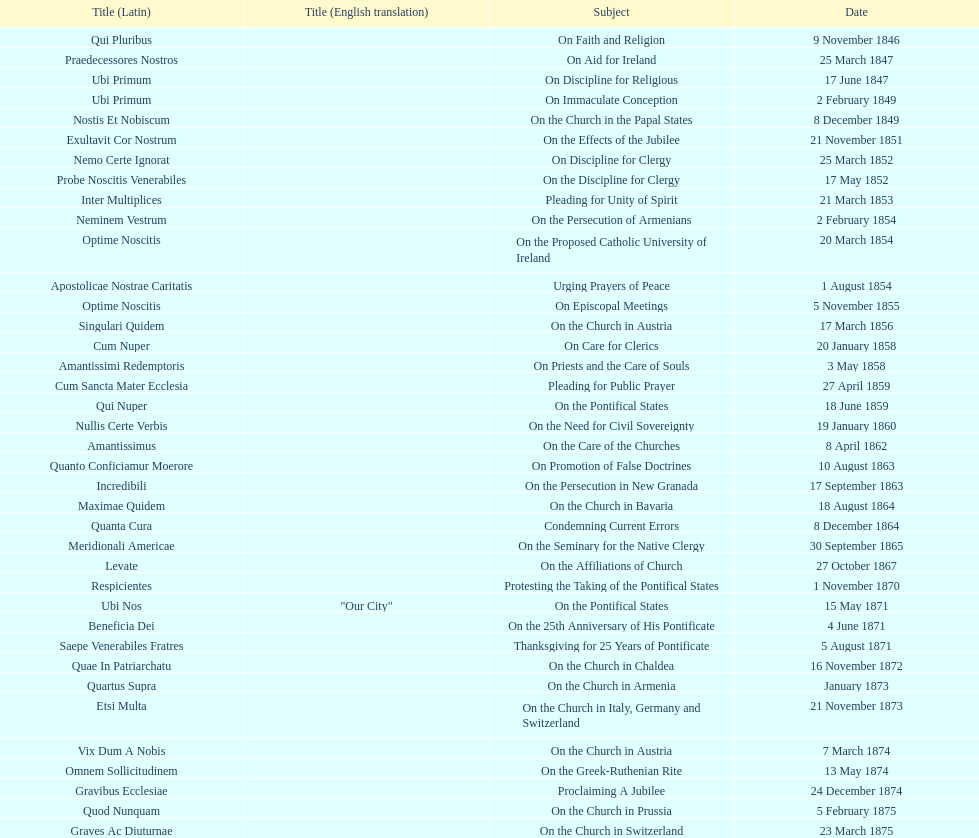What is the previous subject after on the effects of the jubilee? On the Church in the Papal States. 